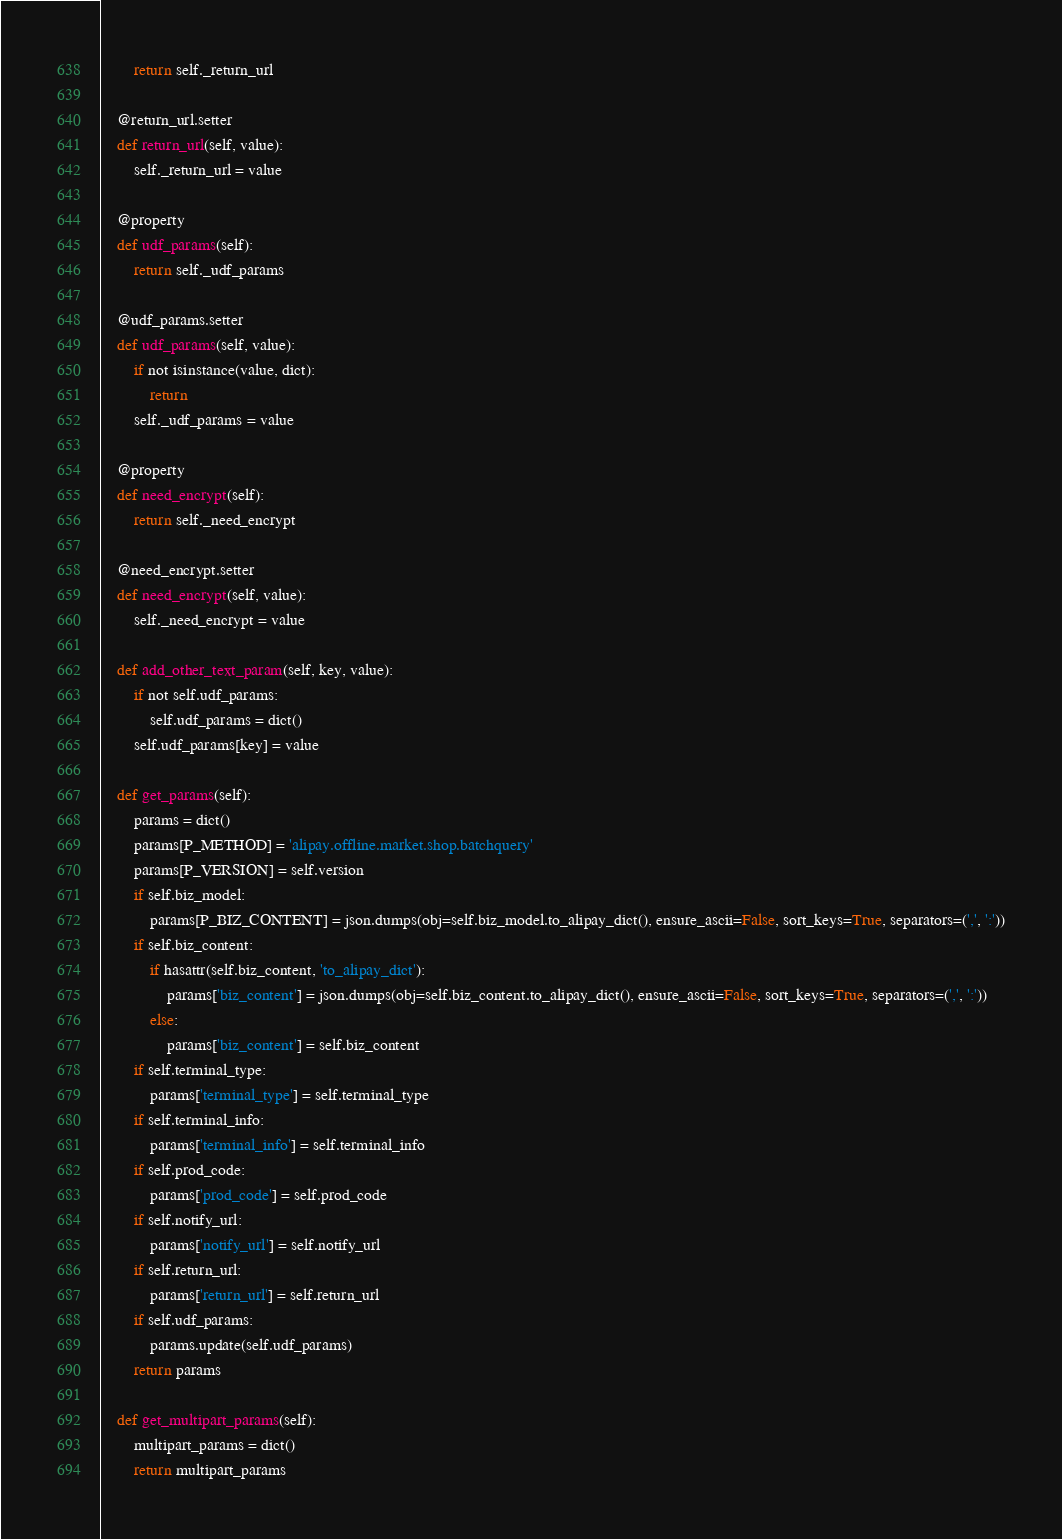Convert code to text. <code><loc_0><loc_0><loc_500><loc_500><_Python_>        return self._return_url

    @return_url.setter
    def return_url(self, value):
        self._return_url = value

    @property
    def udf_params(self):
        return self._udf_params

    @udf_params.setter
    def udf_params(self, value):
        if not isinstance(value, dict):
            return
        self._udf_params = value

    @property
    def need_encrypt(self):
        return self._need_encrypt

    @need_encrypt.setter
    def need_encrypt(self, value):
        self._need_encrypt = value

    def add_other_text_param(self, key, value):
        if not self.udf_params:
            self.udf_params = dict()
        self.udf_params[key] = value

    def get_params(self):
        params = dict()
        params[P_METHOD] = 'alipay.offline.market.shop.batchquery'
        params[P_VERSION] = self.version
        if self.biz_model:
            params[P_BIZ_CONTENT] = json.dumps(obj=self.biz_model.to_alipay_dict(), ensure_ascii=False, sort_keys=True, separators=(',', ':'))
        if self.biz_content:
            if hasattr(self.biz_content, 'to_alipay_dict'):
                params['biz_content'] = json.dumps(obj=self.biz_content.to_alipay_dict(), ensure_ascii=False, sort_keys=True, separators=(',', ':'))
            else:
                params['biz_content'] = self.biz_content
        if self.terminal_type:
            params['terminal_type'] = self.terminal_type
        if self.terminal_info:
            params['terminal_info'] = self.terminal_info
        if self.prod_code:
            params['prod_code'] = self.prod_code
        if self.notify_url:
            params['notify_url'] = self.notify_url
        if self.return_url:
            params['return_url'] = self.return_url
        if self.udf_params:
            params.update(self.udf_params)
        return params

    def get_multipart_params(self):
        multipart_params = dict()
        return multipart_params
</code> 